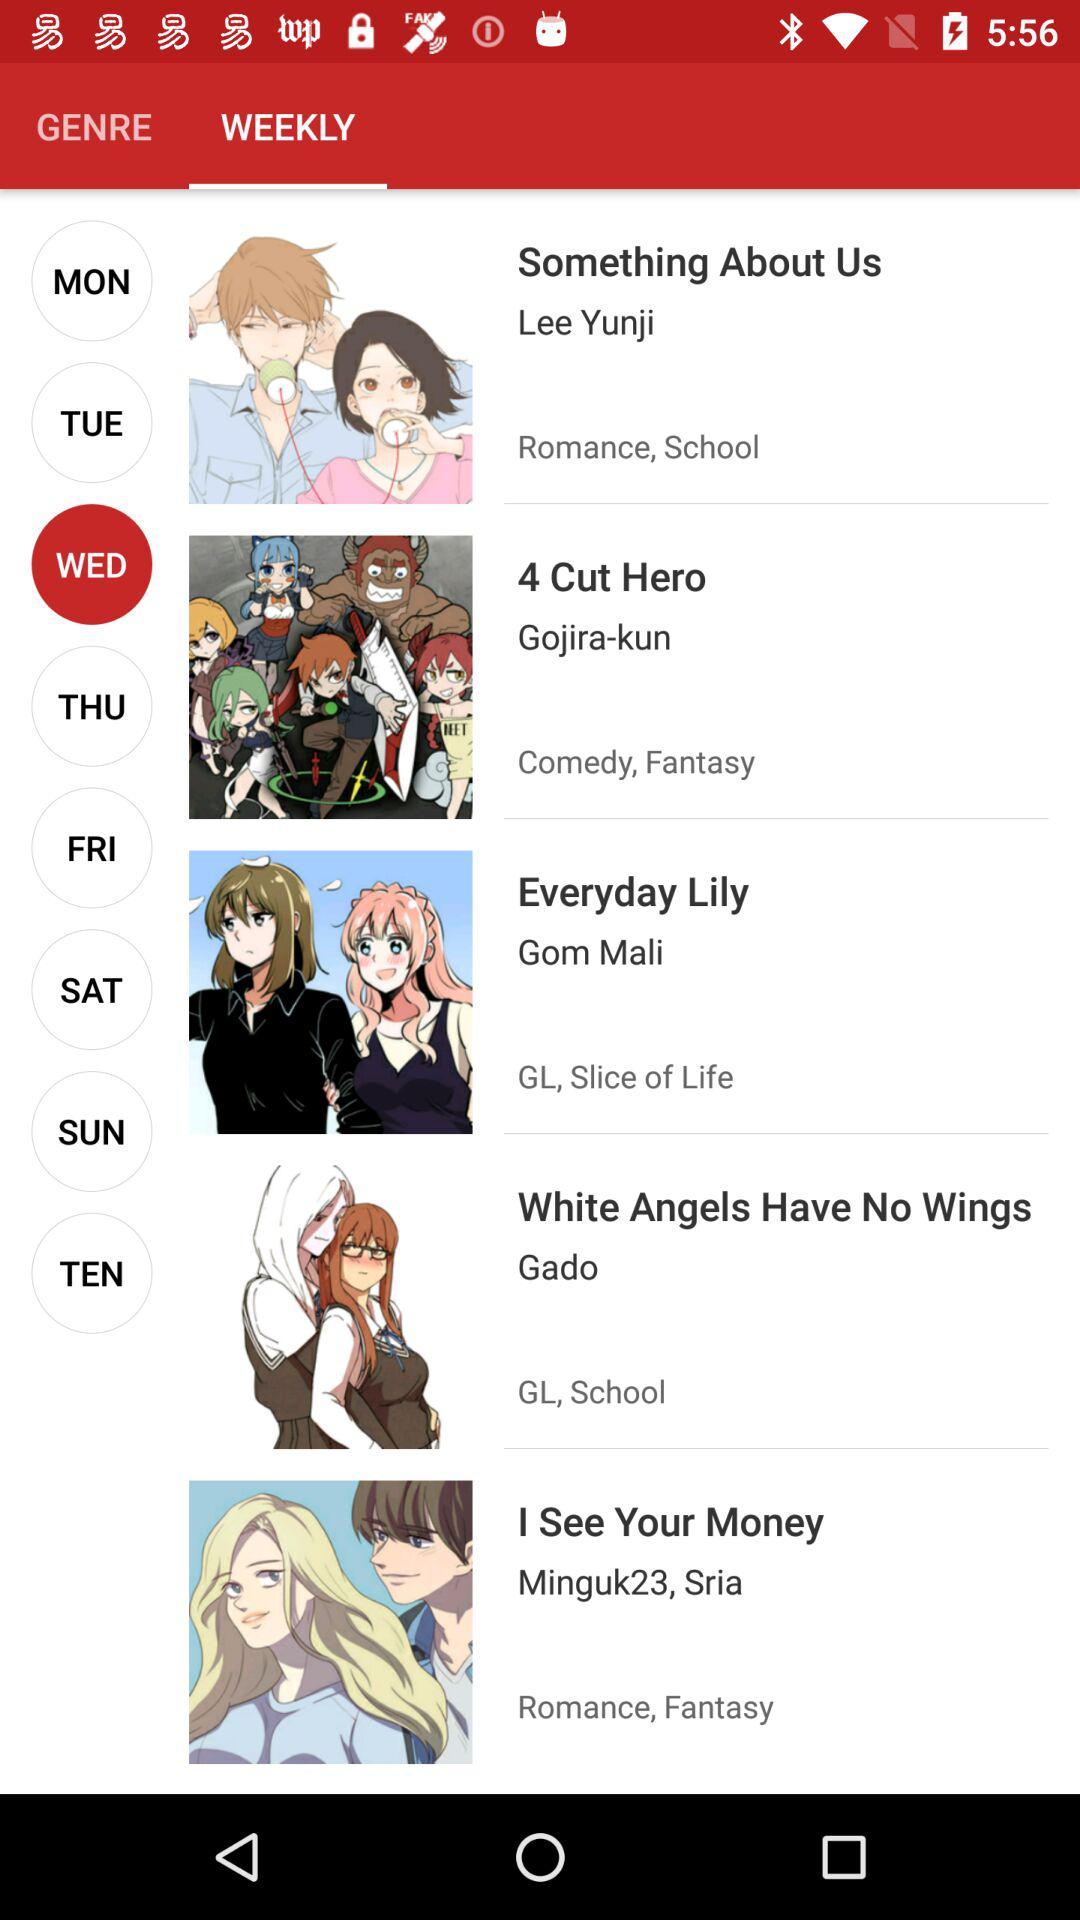How many items are in "GENRE"?
When the provided information is insufficient, respond with <no answer>. <no answer> 